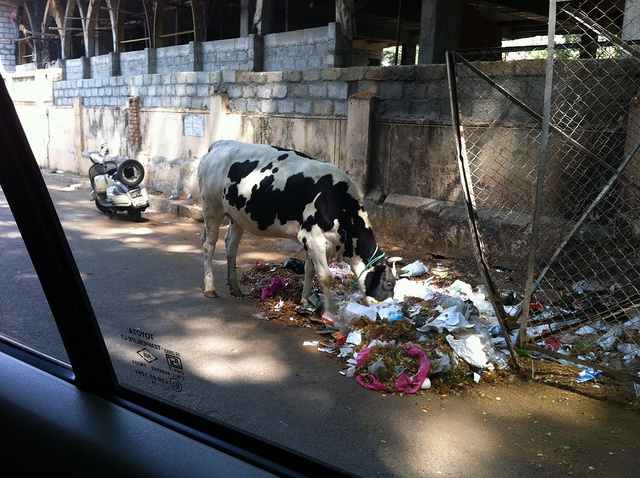Describe the objects in this image and their specific colors. I can see cow in black, gray, darkgray, and white tones and motorcycle in black, gray, white, and darkgray tones in this image. 